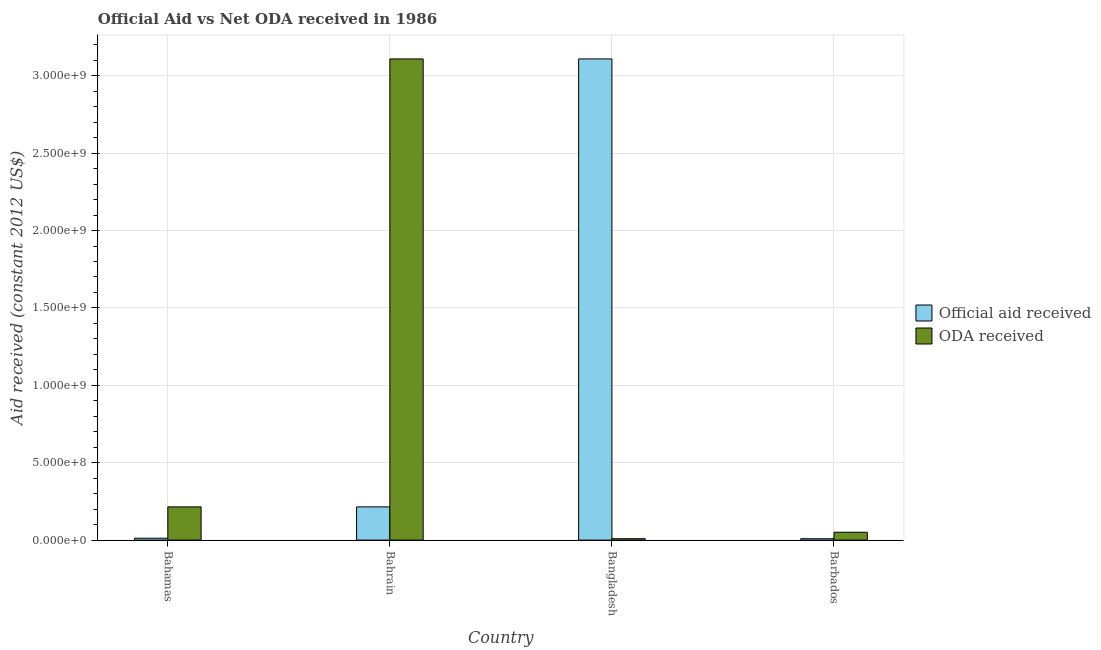How many bars are there on the 4th tick from the left?
Offer a terse response. 2. How many bars are there on the 4th tick from the right?
Offer a very short reply. 2. What is the label of the 3rd group of bars from the left?
Keep it short and to the point. Bangladesh. What is the official aid received in Bahrain?
Offer a very short reply. 2.15e+08. Across all countries, what is the maximum official aid received?
Your answer should be compact. 3.11e+09. Across all countries, what is the minimum official aid received?
Your answer should be compact. 8.85e+06. In which country was the oda received maximum?
Offer a very short reply. Bahrain. In which country was the official aid received minimum?
Provide a succinct answer. Barbados. What is the total official aid received in the graph?
Provide a succinct answer. 3.34e+09. What is the difference between the oda received in Bahamas and that in Bahrain?
Your response must be concise. -2.89e+09. What is the difference between the official aid received in Bangladesh and the oda received in Bahamas?
Give a very brief answer. 2.89e+09. What is the average oda received per country?
Give a very brief answer. 8.46e+08. What is the difference between the oda received and official aid received in Barbados?
Give a very brief answer. 4.19e+07. In how many countries, is the official aid received greater than 100000000 US$?
Your answer should be very brief. 2. What is the ratio of the official aid received in Bahamas to that in Bangladesh?
Give a very brief answer. 0. What is the difference between the highest and the second highest oda received?
Your answer should be very brief. 2.89e+09. What is the difference between the highest and the lowest oda received?
Offer a terse response. 3.10e+09. In how many countries, is the oda received greater than the average oda received taken over all countries?
Your answer should be compact. 1. Is the sum of the official aid received in Bahamas and Bangladesh greater than the maximum oda received across all countries?
Give a very brief answer. Yes. What does the 2nd bar from the left in Barbados represents?
Your answer should be very brief. ODA received. What does the 2nd bar from the right in Bahamas represents?
Make the answer very short. Official aid received. How many bars are there?
Provide a short and direct response. 8. Are all the bars in the graph horizontal?
Your answer should be very brief. No. What is the difference between two consecutive major ticks on the Y-axis?
Give a very brief answer. 5.00e+08. Are the values on the major ticks of Y-axis written in scientific E-notation?
Your response must be concise. Yes. Does the graph contain grids?
Give a very brief answer. Yes. How are the legend labels stacked?
Provide a succinct answer. Vertical. What is the title of the graph?
Give a very brief answer. Official Aid vs Net ODA received in 1986 . Does "Money lenders" appear as one of the legend labels in the graph?
Offer a very short reply. No. What is the label or title of the X-axis?
Your response must be concise. Country. What is the label or title of the Y-axis?
Your response must be concise. Aid received (constant 2012 US$). What is the Aid received (constant 2012 US$) in Official aid received in Bahamas?
Keep it short and to the point. 1.23e+07. What is the Aid received (constant 2012 US$) of ODA received in Bahamas?
Provide a short and direct response. 2.15e+08. What is the Aid received (constant 2012 US$) of Official aid received in Bahrain?
Your answer should be compact. 2.15e+08. What is the Aid received (constant 2012 US$) in ODA received in Bahrain?
Provide a short and direct response. 3.11e+09. What is the Aid received (constant 2012 US$) in Official aid received in Bangladesh?
Ensure brevity in your answer.  3.11e+09. What is the Aid received (constant 2012 US$) of ODA received in Bangladesh?
Offer a terse response. 8.85e+06. What is the Aid received (constant 2012 US$) of Official aid received in Barbados?
Keep it short and to the point. 8.85e+06. What is the Aid received (constant 2012 US$) in ODA received in Barbados?
Your answer should be compact. 5.08e+07. Across all countries, what is the maximum Aid received (constant 2012 US$) in Official aid received?
Provide a short and direct response. 3.11e+09. Across all countries, what is the maximum Aid received (constant 2012 US$) in ODA received?
Offer a very short reply. 3.11e+09. Across all countries, what is the minimum Aid received (constant 2012 US$) in Official aid received?
Keep it short and to the point. 8.85e+06. Across all countries, what is the minimum Aid received (constant 2012 US$) of ODA received?
Keep it short and to the point. 8.85e+06. What is the total Aid received (constant 2012 US$) in Official aid received in the graph?
Your response must be concise. 3.34e+09. What is the total Aid received (constant 2012 US$) in ODA received in the graph?
Give a very brief answer. 3.38e+09. What is the difference between the Aid received (constant 2012 US$) of Official aid received in Bahamas and that in Bahrain?
Your answer should be very brief. -2.02e+08. What is the difference between the Aid received (constant 2012 US$) of ODA received in Bahamas and that in Bahrain?
Keep it short and to the point. -2.89e+09. What is the difference between the Aid received (constant 2012 US$) of Official aid received in Bahamas and that in Bangladesh?
Make the answer very short. -3.10e+09. What is the difference between the Aid received (constant 2012 US$) of ODA received in Bahamas and that in Bangladesh?
Your answer should be compact. 2.06e+08. What is the difference between the Aid received (constant 2012 US$) in Official aid received in Bahamas and that in Barbados?
Give a very brief answer. 3.45e+06. What is the difference between the Aid received (constant 2012 US$) in ODA received in Bahamas and that in Barbados?
Ensure brevity in your answer.  1.64e+08. What is the difference between the Aid received (constant 2012 US$) of Official aid received in Bahrain and that in Bangladesh?
Ensure brevity in your answer.  -2.89e+09. What is the difference between the Aid received (constant 2012 US$) in ODA received in Bahrain and that in Bangladesh?
Your answer should be compact. 3.10e+09. What is the difference between the Aid received (constant 2012 US$) of Official aid received in Bahrain and that in Barbados?
Keep it short and to the point. 2.06e+08. What is the difference between the Aid received (constant 2012 US$) of ODA received in Bahrain and that in Barbados?
Your answer should be very brief. 3.06e+09. What is the difference between the Aid received (constant 2012 US$) of Official aid received in Bangladesh and that in Barbados?
Your answer should be compact. 3.10e+09. What is the difference between the Aid received (constant 2012 US$) of ODA received in Bangladesh and that in Barbados?
Give a very brief answer. -4.19e+07. What is the difference between the Aid received (constant 2012 US$) of Official aid received in Bahamas and the Aid received (constant 2012 US$) of ODA received in Bahrain?
Your answer should be very brief. -3.10e+09. What is the difference between the Aid received (constant 2012 US$) of Official aid received in Bahamas and the Aid received (constant 2012 US$) of ODA received in Bangladesh?
Offer a terse response. 3.45e+06. What is the difference between the Aid received (constant 2012 US$) of Official aid received in Bahamas and the Aid received (constant 2012 US$) of ODA received in Barbados?
Your answer should be very brief. -3.85e+07. What is the difference between the Aid received (constant 2012 US$) in Official aid received in Bahrain and the Aid received (constant 2012 US$) in ODA received in Bangladesh?
Your response must be concise. 2.06e+08. What is the difference between the Aid received (constant 2012 US$) of Official aid received in Bahrain and the Aid received (constant 2012 US$) of ODA received in Barbados?
Offer a very short reply. 1.64e+08. What is the difference between the Aid received (constant 2012 US$) of Official aid received in Bangladesh and the Aid received (constant 2012 US$) of ODA received in Barbados?
Provide a short and direct response. 3.06e+09. What is the average Aid received (constant 2012 US$) of Official aid received per country?
Make the answer very short. 8.36e+08. What is the average Aid received (constant 2012 US$) in ODA received per country?
Your answer should be compact. 8.46e+08. What is the difference between the Aid received (constant 2012 US$) of Official aid received and Aid received (constant 2012 US$) of ODA received in Bahamas?
Give a very brief answer. -2.02e+08. What is the difference between the Aid received (constant 2012 US$) in Official aid received and Aid received (constant 2012 US$) in ODA received in Bahrain?
Give a very brief answer. -2.89e+09. What is the difference between the Aid received (constant 2012 US$) in Official aid received and Aid received (constant 2012 US$) in ODA received in Bangladesh?
Your answer should be compact. 3.10e+09. What is the difference between the Aid received (constant 2012 US$) of Official aid received and Aid received (constant 2012 US$) of ODA received in Barbados?
Provide a short and direct response. -4.19e+07. What is the ratio of the Aid received (constant 2012 US$) of Official aid received in Bahamas to that in Bahrain?
Ensure brevity in your answer.  0.06. What is the ratio of the Aid received (constant 2012 US$) of ODA received in Bahamas to that in Bahrain?
Offer a terse response. 0.07. What is the ratio of the Aid received (constant 2012 US$) in Official aid received in Bahamas to that in Bangladesh?
Make the answer very short. 0. What is the ratio of the Aid received (constant 2012 US$) of ODA received in Bahamas to that in Bangladesh?
Your response must be concise. 24.25. What is the ratio of the Aid received (constant 2012 US$) of Official aid received in Bahamas to that in Barbados?
Ensure brevity in your answer.  1.39. What is the ratio of the Aid received (constant 2012 US$) in ODA received in Bahamas to that in Barbados?
Make the answer very short. 4.23. What is the ratio of the Aid received (constant 2012 US$) of Official aid received in Bahrain to that in Bangladesh?
Keep it short and to the point. 0.07. What is the ratio of the Aid received (constant 2012 US$) in ODA received in Bahrain to that in Bangladesh?
Ensure brevity in your answer.  351.28. What is the ratio of the Aid received (constant 2012 US$) in Official aid received in Bahrain to that in Barbados?
Keep it short and to the point. 24.25. What is the ratio of the Aid received (constant 2012 US$) of ODA received in Bahrain to that in Barbados?
Ensure brevity in your answer.  61.21. What is the ratio of the Aid received (constant 2012 US$) in Official aid received in Bangladesh to that in Barbados?
Make the answer very short. 351.28. What is the ratio of the Aid received (constant 2012 US$) of ODA received in Bangladesh to that in Barbados?
Keep it short and to the point. 0.17. What is the difference between the highest and the second highest Aid received (constant 2012 US$) of Official aid received?
Your response must be concise. 2.89e+09. What is the difference between the highest and the second highest Aid received (constant 2012 US$) in ODA received?
Your response must be concise. 2.89e+09. What is the difference between the highest and the lowest Aid received (constant 2012 US$) in Official aid received?
Your answer should be compact. 3.10e+09. What is the difference between the highest and the lowest Aid received (constant 2012 US$) in ODA received?
Ensure brevity in your answer.  3.10e+09. 